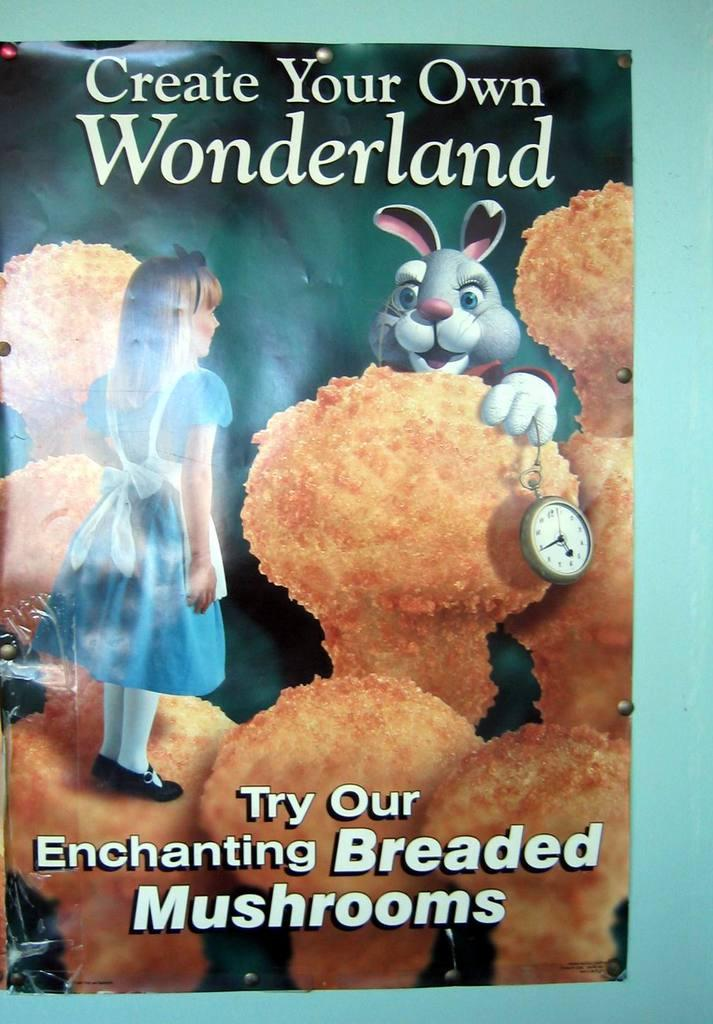<image>
Give a short and clear explanation of the subsequent image. A picture of Alice in Wonderland convinces consumers to try their Enchanting Breaded Mushrooms 